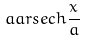<formula> <loc_0><loc_0><loc_500><loc_500>a a r s e c h \frac { x } { a }</formula> 